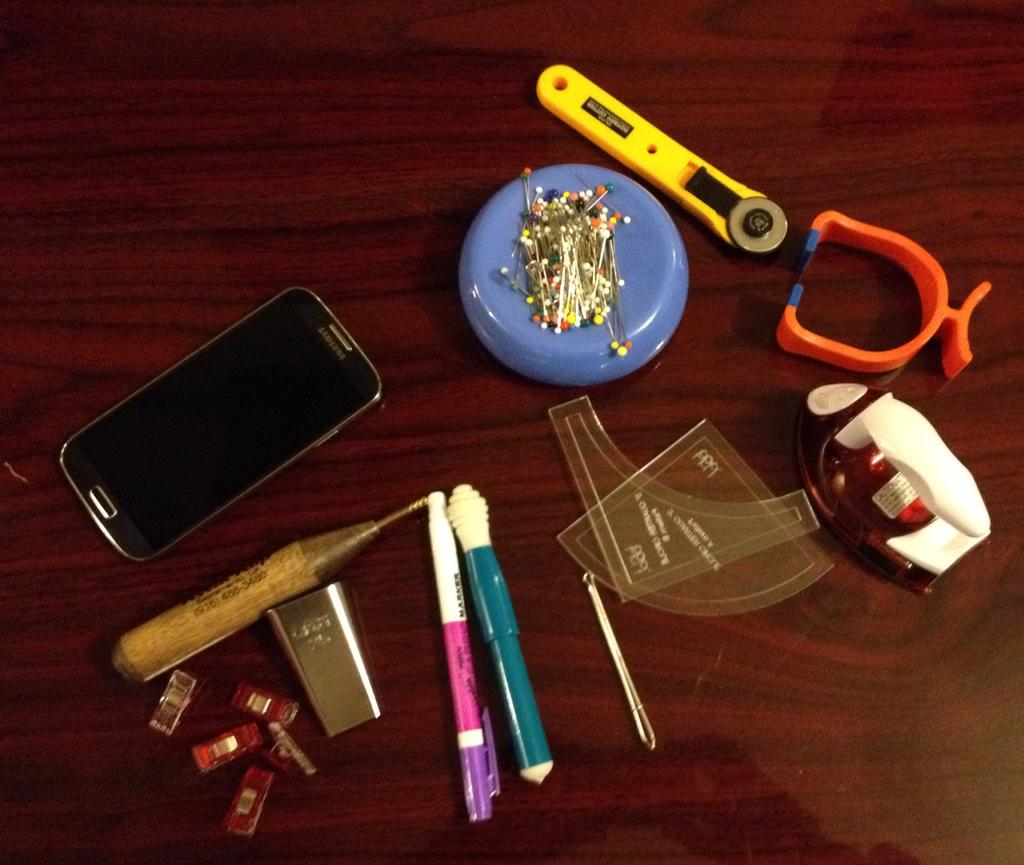What is the main object in the image? There is a mobile in the image. What other items can be seen in the image? There is a magnet with plastic head pins and a pen in the image. Are there any other objects present on a wooden board? Yes, there are other objects on a wooden board in the image. What type of toothpaste is being used to clean the stone in the image? There is no toothpaste or stone present in the image. 